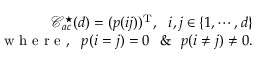<formula> <loc_0><loc_0><loc_500><loc_500>\begin{array} { r } { \mathcal { C } _ { a c } ^ { ^ { * } } ( d ) = ( p ( i j ) ) ^ { T } , i , j \in \{ 1 , \cdots , d \} } \\ { w h e r e , p ( i = j ) = 0 \& p ( i \neq j ) \neq 0 . } \end{array}</formula> 